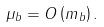Convert formula to latex. <formula><loc_0><loc_0><loc_500><loc_500>\mu _ { b } = O \left ( m _ { b } \right ) .</formula> 